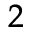Convert formula to latex. <formula><loc_0><loc_0><loc_500><loc_500>^ { 2 }</formula> 